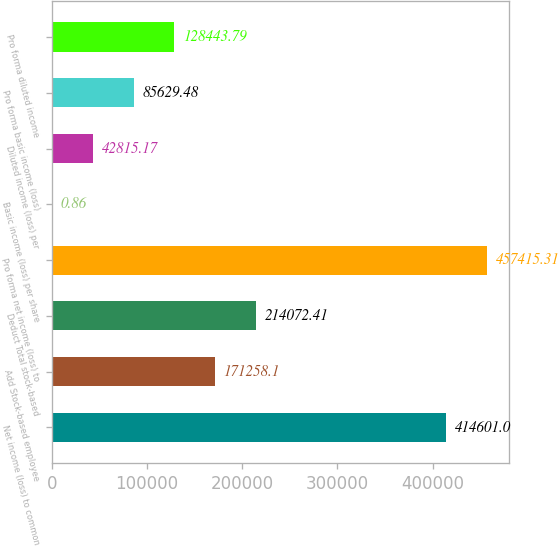<chart> <loc_0><loc_0><loc_500><loc_500><bar_chart><fcel>Net income (loss) to common<fcel>Add Stock-based employee<fcel>Deduct Total stock-based<fcel>Pro forma net income (loss) to<fcel>Basic income (loss) per share<fcel>Diluted income (loss) per<fcel>Pro forma basic income (loss)<fcel>Pro forma diluted income<nl><fcel>414601<fcel>171258<fcel>214072<fcel>457415<fcel>0.86<fcel>42815.2<fcel>85629.5<fcel>128444<nl></chart> 